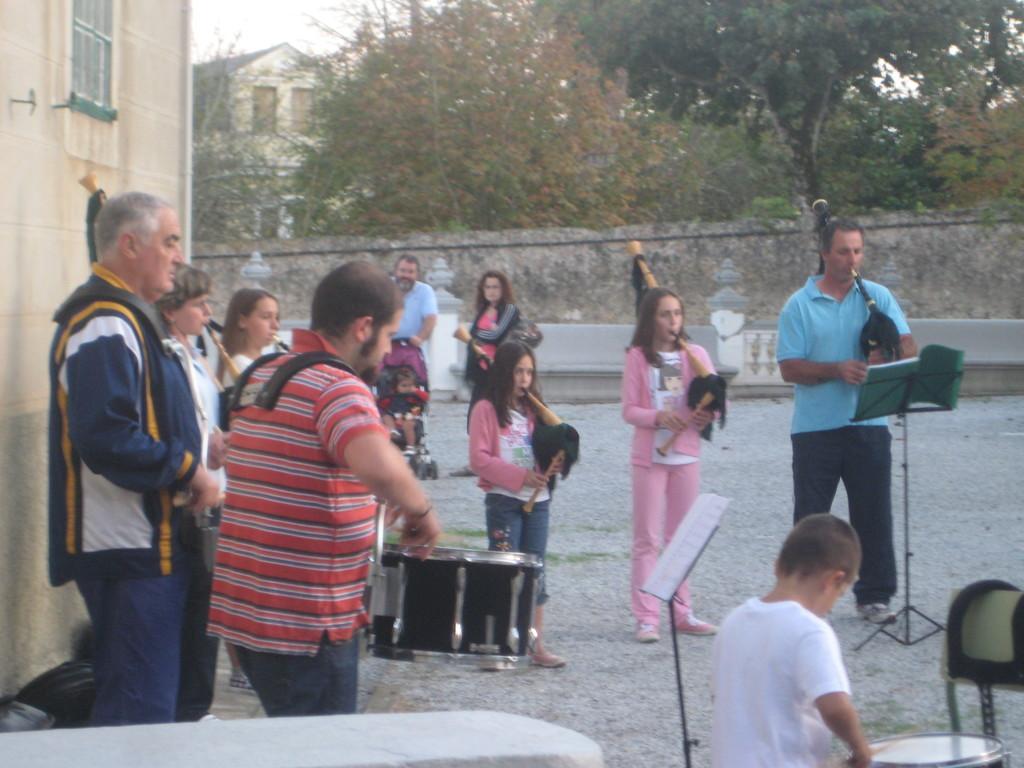Please provide a concise description of this image. In this picture, there are group of people playing musical instruments. Towards the left, there is a man in red t shirt is playing drums. At the bottom right, there is a kid in white t shirt, playing a drum. Towards the right, there is another man in blue t shirt playing a trumpet. In the background, there are buildings, trees, wall and sky etc. 